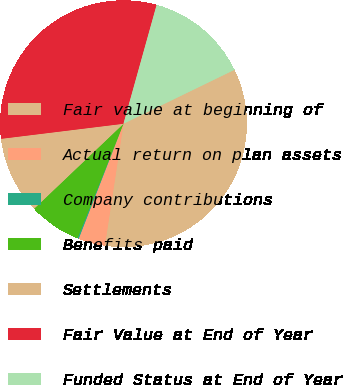Convert chart. <chart><loc_0><loc_0><loc_500><loc_500><pie_chart><fcel>Fair value at beginning of<fcel>Actual return on plan assets<fcel>Company contributions<fcel>Benefits paid<fcel>Settlements<fcel>Fair Value at End of Year<fcel>Funded Status at End of Year<nl><fcel>34.61%<fcel>3.5%<fcel>0.17%<fcel>6.82%<fcel>10.15%<fcel>31.28%<fcel>13.47%<nl></chart> 